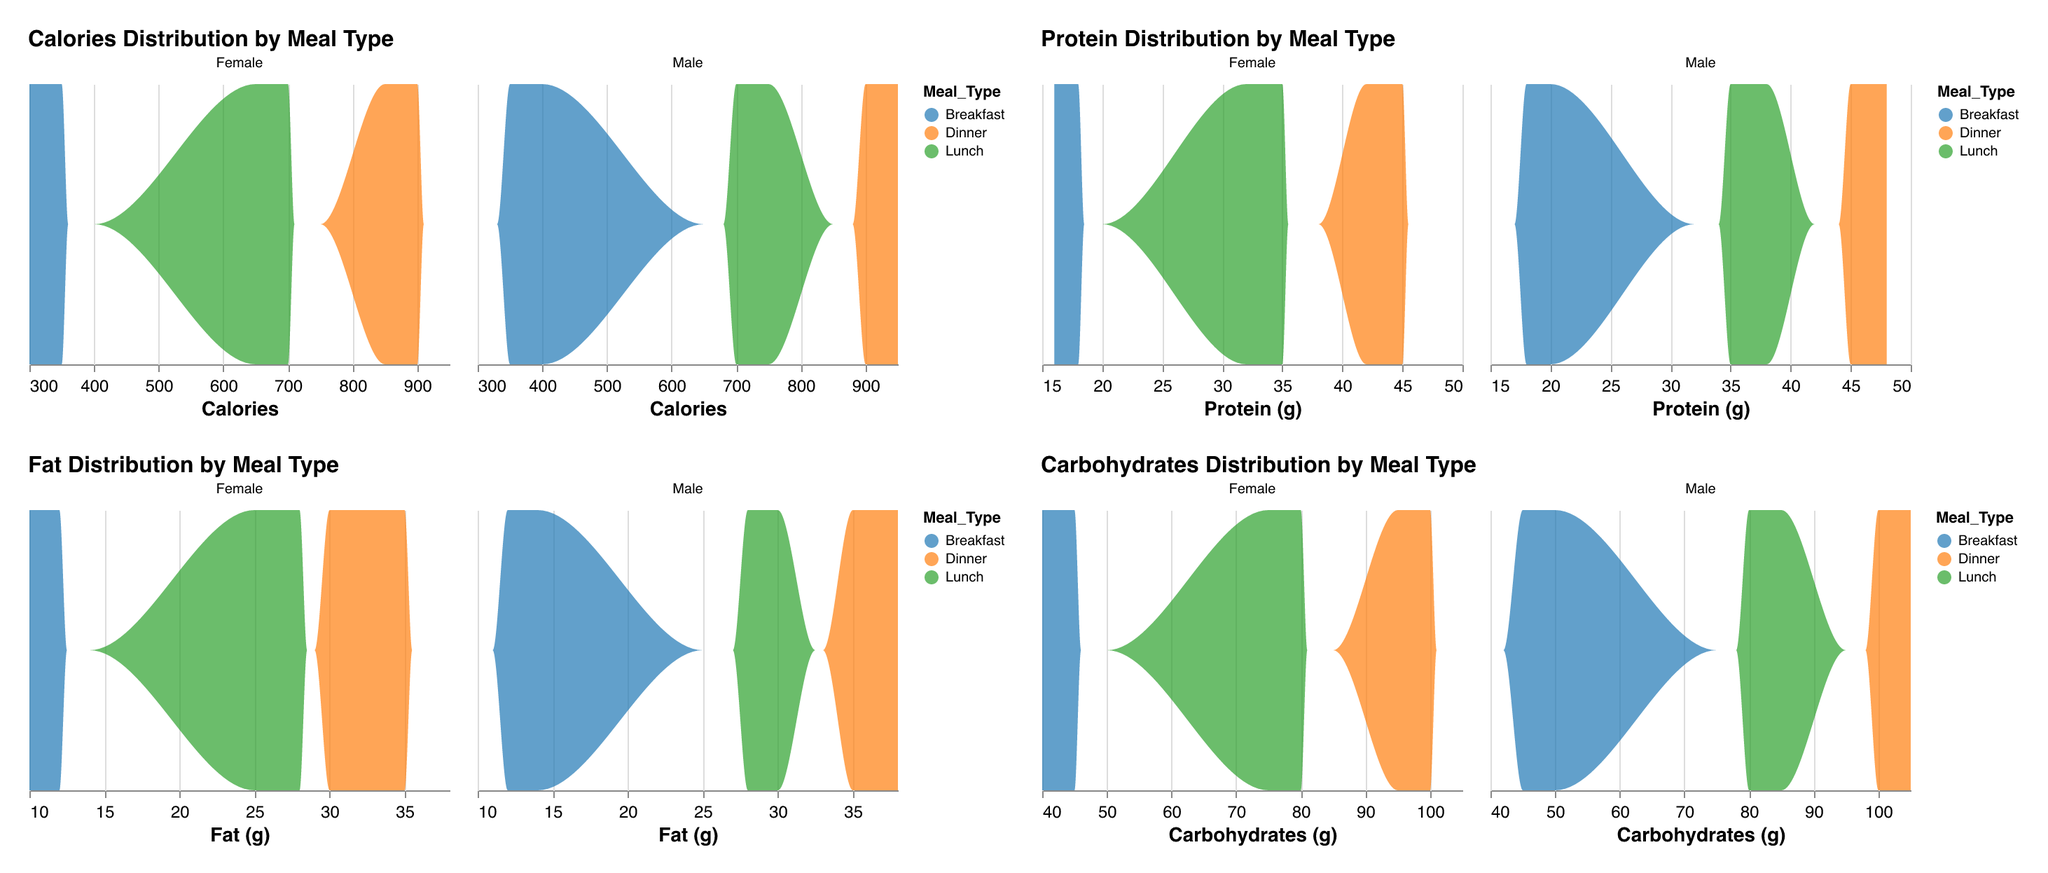What's the range of Calories intake for breakfast meals? The range of a dataset is the difference between the maximum and minimum values. For breakfast meals, the minimum Calories intake is 300 (Female, 15-24) and the maximum is 400 (Male, 25-34). Therefore, the range is 400 - 300 = 100.
Answer: 100 Which meal type has the highest protein density? From observing the density plot of protein intake, dinner meals consistently have the highest peaks across both genders, indicating a higher density of protein intake.
Answer: Dinner How does the Fat intake distribution for lunch compare between males and females? The density plots for Fat intake for lunch show that males have a slightly higher density peak which indicates a higher average intake compared to females. Both genders, however, show peaks around similar values.
Answer: Males have a slightly higher Fat intake for lunch Identify the meal type with the lowest Carbohydrates intake by meal type and gender from the plot. By examining the density plot for Carbohydrates intake, it is clear that breakfast has the lowest Carbohydrates peaks across both genders, indicating the lower Carbohydrates intake during breakfast compared to other meals.
Answer: Breakfast What is the most frequent Protein intake range for males during dinner? By looking at the density plot for Protein intake during dinner for males, the highest peak is around 45-48 grams of protein, making it the most frequent range for males.
Answer: 45-48 grams Compare the Calories distribution by gender for lunch. The density plot for Calories distribution shows that both genders have a significant density around 700-750 for lunch. However, males have a slightly higher density, indicating higher average Calories intake compared to females.
Answer: Males have a slightly higher Calories intake for lunch Is there a noticeable difference in Carbohydrates intake between meal types? By examining the density plots for Carbohydrates intake, breakfast consistently shows lower peaks compared to both lunch and dinner, indicating a noticeable difference with lower Carbohydrates intake at breakfast.
Answer: Yes, breakfast has lower Carbohydrates intake For which gender and meal type is the fat distribution the widest? Observing the density plots for Fat intake, the dinner meal type for males shows a wider distribution, indicating a greater variability of fat intake during dinner among males.
Answer: Males, dinner Based on the plot, what is the general trend of nutritional intake across different meal types? The general trend indicates that nutritional intake, including Calories, Protein, Fat, and Carbohydrates, tends to increase from breakfast to dinner. This can be inferred from the increasing peaks and wider distributions from breakfast to dinner.
Answer: Increase from breakfast to dinner 